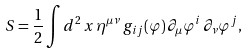Convert formula to latex. <formula><loc_0><loc_0><loc_500><loc_500>S = { \frac { 1 } { 2 } } \int d ^ { 2 } \, x \, \eta ^ { \mu \nu } \, g _ { i j } ( \varphi ) \, \partial _ { \mu } \varphi ^ { i } \, \partial _ { \nu } \varphi ^ { j } ,</formula> 